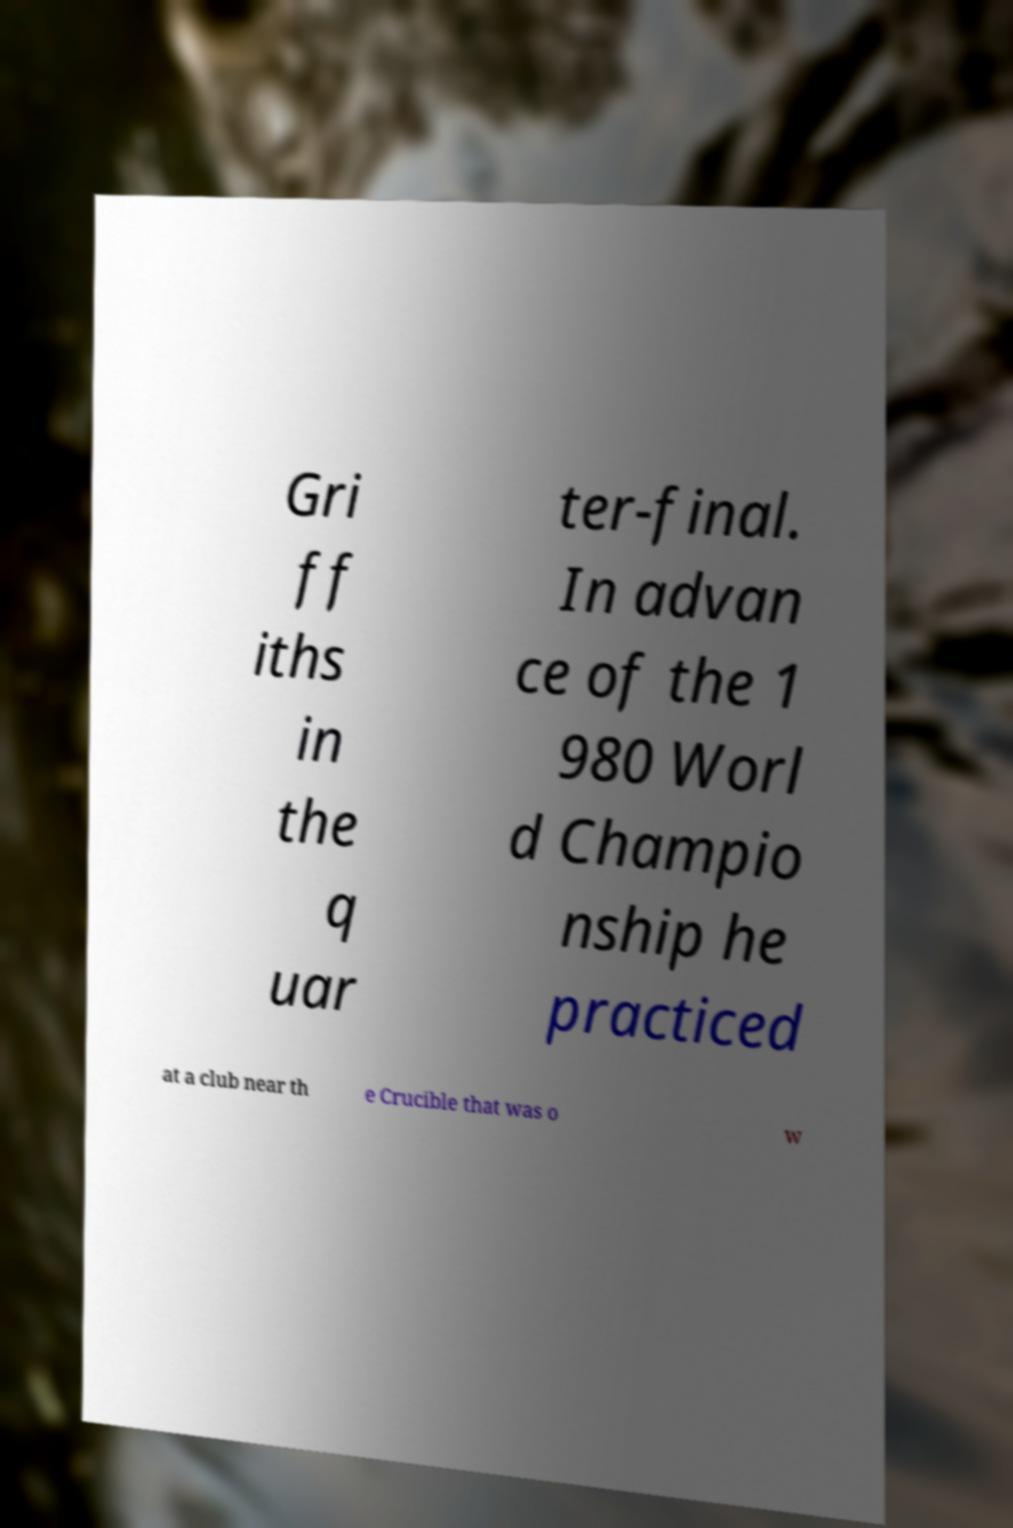Please read and relay the text visible in this image. What does it say? Gri ff iths in the q uar ter-final. In advan ce of the 1 980 Worl d Champio nship he practiced at a club near th e Crucible that was o w 